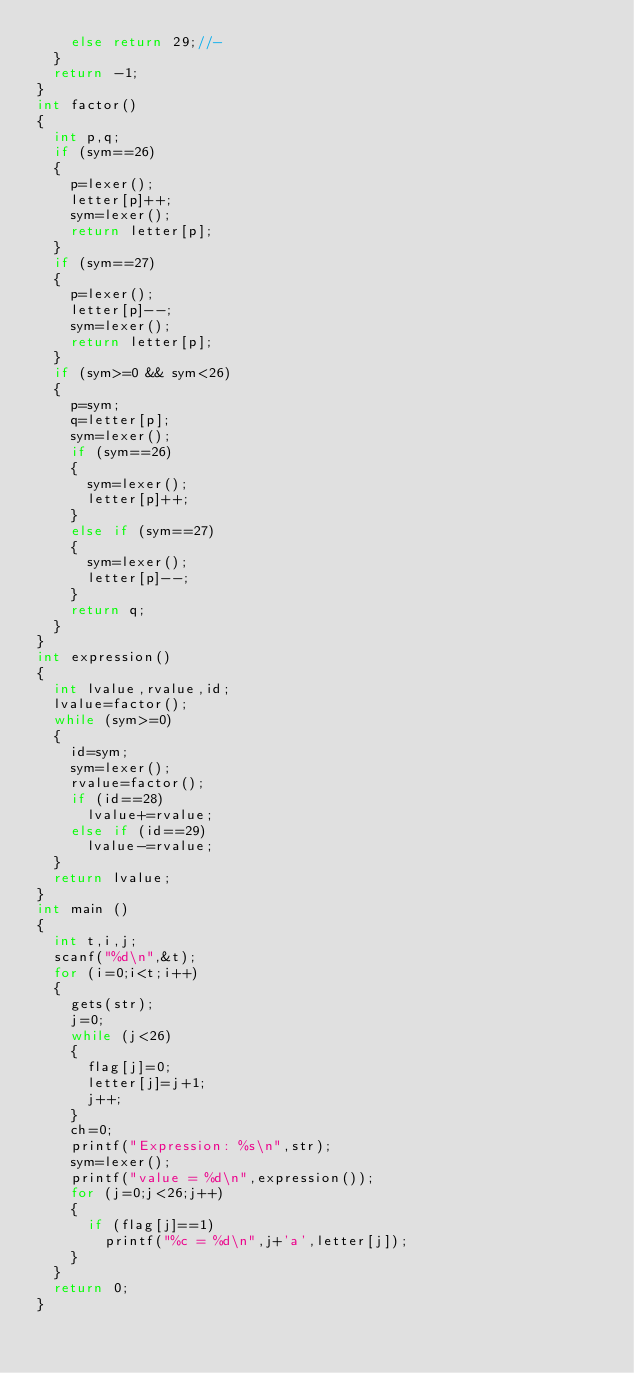Convert code to text. <code><loc_0><loc_0><loc_500><loc_500><_C_>		else return 29;//-
	}
	return -1;
}
int factor()
{
	int p,q;
	if (sym==26)
	{
		p=lexer();
		letter[p]++;
		sym=lexer();
		return letter[p];
	}
	if (sym==27)
	{
		p=lexer();
		letter[p]--;
		sym=lexer();
		return letter[p];
	}
	if (sym>=0 && sym<26)
	{
		p=sym;
		q=letter[p];
		sym=lexer();
		if (sym==26)
		{
			sym=lexer();
			letter[p]++;
		}
		else if (sym==27)
		{
			sym=lexer();
			letter[p]--;
		}
		return q;
	}
}
int expression()
{
	int lvalue,rvalue,id;
	lvalue=factor();
	while (sym>=0)
	{
		id=sym;
		sym=lexer();
		rvalue=factor();
		if (id==28)
			lvalue+=rvalue;
		else if (id==29)
			lvalue-=rvalue;
	}
	return lvalue;
}
int main ()
{
	int t,i,j;
	scanf("%d\n",&t);
	for (i=0;i<t;i++)
	{
		gets(str);
		j=0;
		while (j<26)
		{
			flag[j]=0;
			letter[j]=j+1;
			j++;
		}
		ch=0;
		printf("Expression: %s\n",str);
		sym=lexer();
		printf("value = %d\n",expression());
		for (j=0;j<26;j++)
		{
			if (flag[j]==1)
				printf("%c = %d\n",j+'a',letter[j]);
		}
	}
	return 0;
}
</code> 